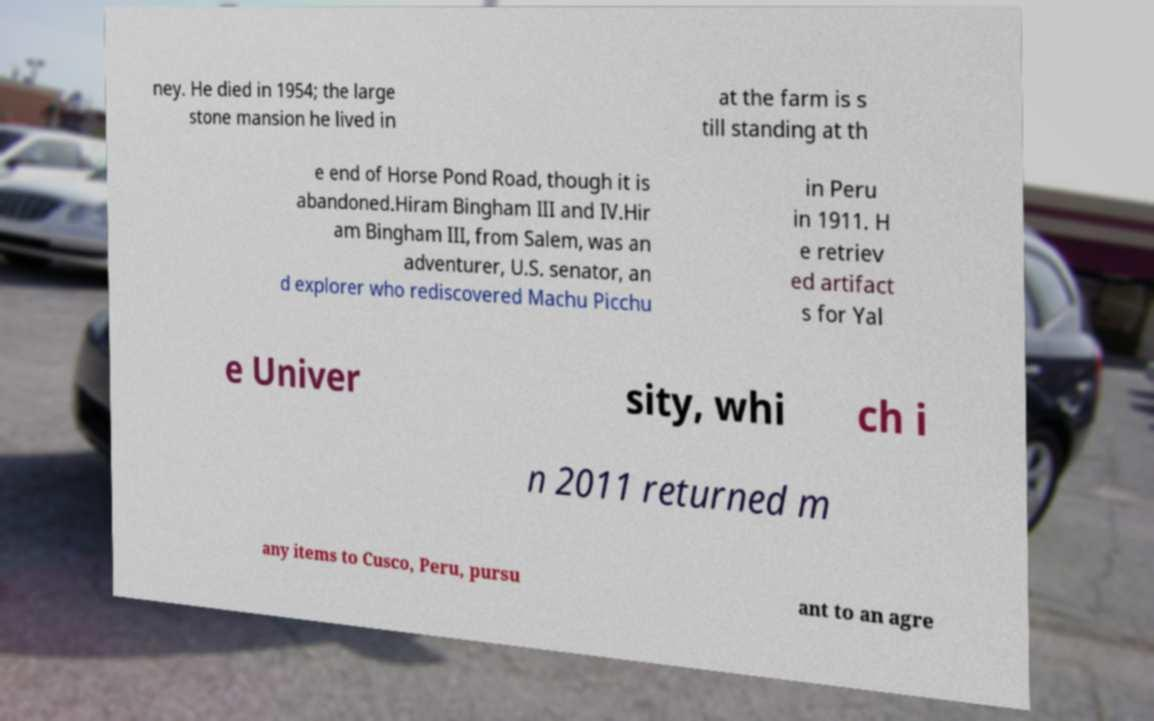For documentation purposes, I need the text within this image transcribed. Could you provide that? ney. He died in 1954; the large stone mansion he lived in at the farm is s till standing at th e end of Horse Pond Road, though it is abandoned.Hiram Bingham III and IV.Hir am Bingham III, from Salem, was an adventurer, U.S. senator, an d explorer who rediscovered Machu Picchu in Peru in 1911. H e retriev ed artifact s for Yal e Univer sity, whi ch i n 2011 returned m any items to Cusco, Peru, pursu ant to an agre 